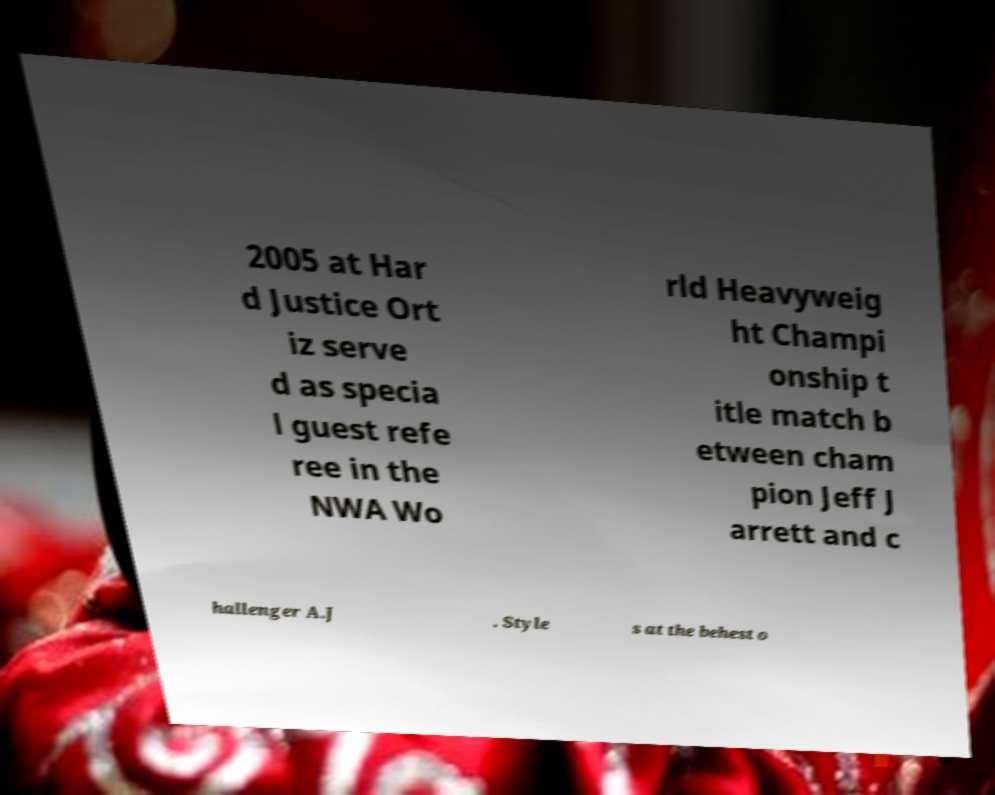Can you accurately transcribe the text from the provided image for me? 2005 at Har d Justice Ort iz serve d as specia l guest refe ree in the NWA Wo rld Heavyweig ht Champi onship t itle match b etween cham pion Jeff J arrett and c hallenger A.J . Style s at the behest o 